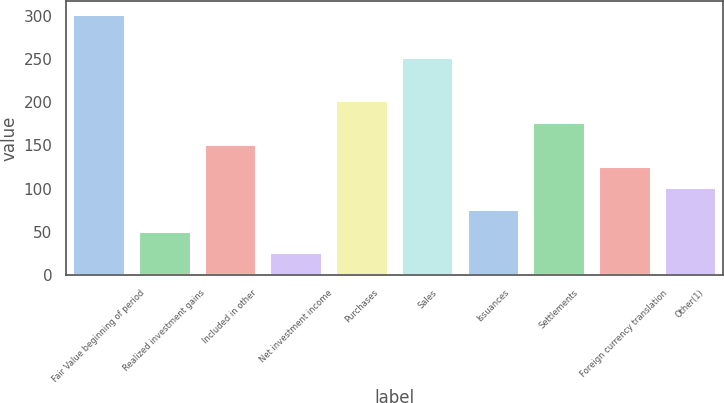Convert chart to OTSL. <chart><loc_0><loc_0><loc_500><loc_500><bar_chart><fcel>Fair Value beginning of period<fcel>Realized investment gains<fcel>Included in other<fcel>Net investment income<fcel>Purchases<fcel>Sales<fcel>Issuances<fcel>Settlements<fcel>Foreign currency translation<fcel>Other(1)<nl><fcel>302.18<fcel>51.41<fcel>151.72<fcel>26.33<fcel>201.88<fcel>252.02<fcel>76.48<fcel>176.8<fcel>126.64<fcel>101.56<nl></chart> 